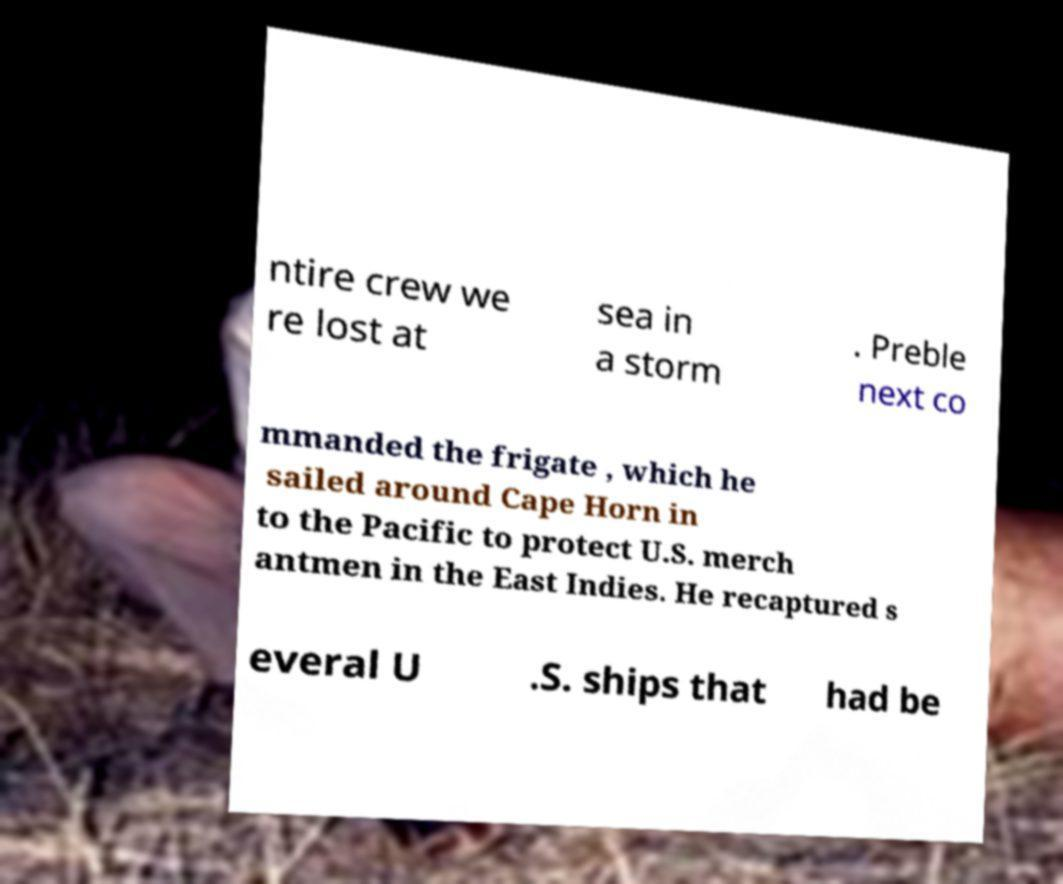For documentation purposes, I need the text within this image transcribed. Could you provide that? ntire crew we re lost at sea in a storm . Preble next co mmanded the frigate , which he sailed around Cape Horn in to the Pacific to protect U.S. merch antmen in the East Indies. He recaptured s everal U .S. ships that had be 